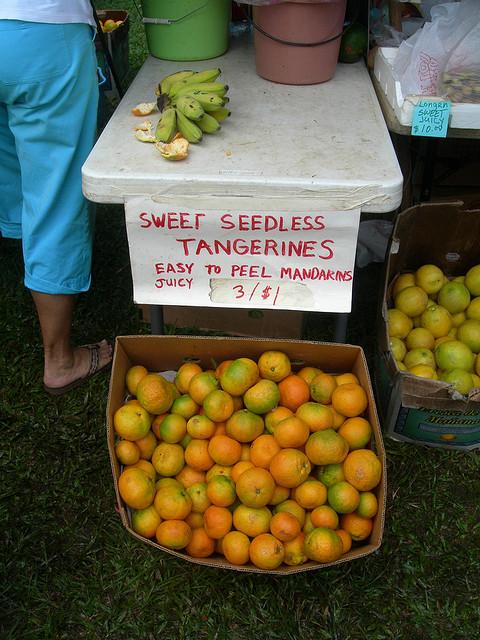What is being sold?
Quick response, please. Tangerines. How much are the tangerines?
Give a very brief answer. 3 for $1. Is the table metal or plastic?
Give a very brief answer. Plastic. 